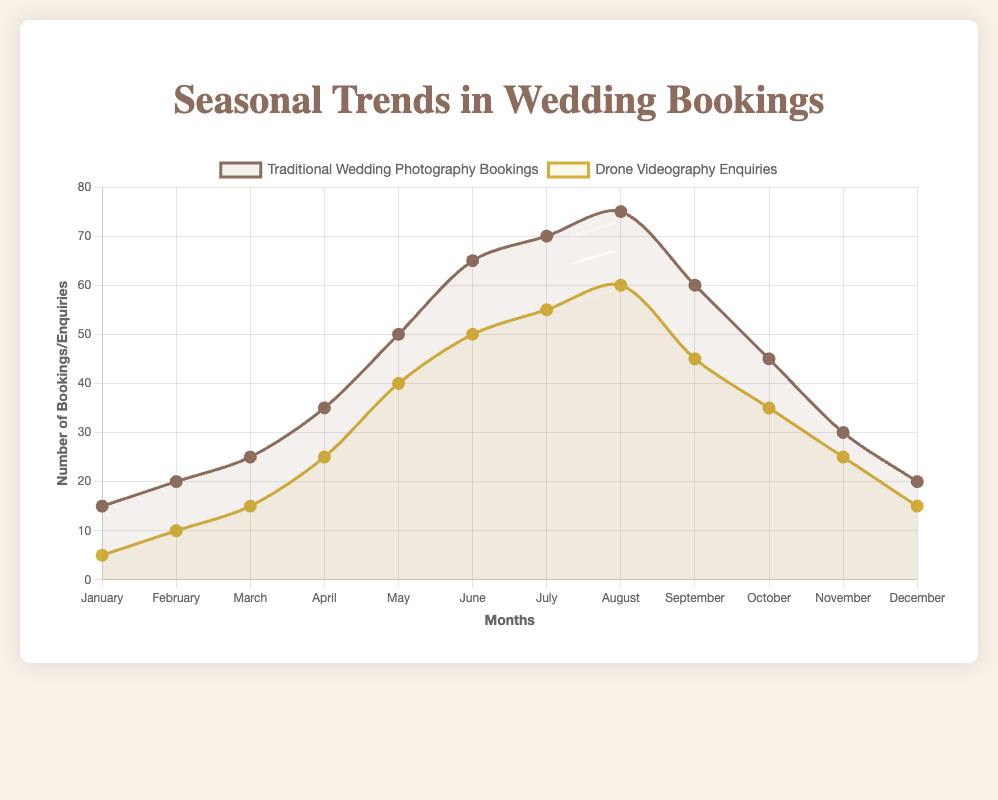What month has the highest number of traditional wedding photography bookings? Observe the line representing traditional wedding photography bookings. The highest point is in August.
Answer: August During which month does the number of drone videography enquiries first surpass 30? Look at the line representing drone videography enquiries. The first month it breaks the 30 mark is May.
Answer: May How does the number of traditional wedding photography bookings in June compare to the number of drone videography enquiries in the same month? In June, traditional wedding photography bookings are 65, and drone videography enquiries are 50. Comparing the two, traditional wedding photography bookings are greater.
Answer: Traditional wedding photography bookings are greater What is the difference between the highest number of traditional wedding photography bookings and the highest number of drone videography enquiries? The peak number for traditional bookings is 75, and for drone enquiries, it is 60. The difference is 75 - 60.
Answer: 15 During which month are the traditional wedding photography bookings equal to the drone videography enquiries? Review the chart for points where the lines intersect. They do not intersect at exact points, indicating no equal bookings in any month.
Answer: No month What is the average number of traditional wedding photography bookings from January to December? Sum the numbers for traditional bookings (15 + 20 + 25 + 35 + 50 + 65 + 70 + 75 + 60 + 45 + 30 + 20) = 510, then divide by 12 months.
Answer: 42.5 Which month sees the biggest discrepancy between traditional wedding photography bookings and drone videography enquiries? Calculate the difference for each month and find the largest: August has 75 traditional bookings and 60 drone enquiries, making the difference 15.
Answer: August What can be inferred about the trend of drone videography enquiries from January to August? The line representing drone videography enquiries shows a steady increase from January (5) to August (60).
Answer: Increasing steadily How many traditional wedding photography bookings are there in the first half of the year compared to the second half? Sum the bookings for Jan-Jun (15 + 20 + 25 + 35 + 50 + 65 = 210) and Jul-Dec (70 + 75 + 60 + 45 + 30 + 20 = 300), then compare the two.
Answer: 210 (first half), 300 (second half) Is there any month where drone videography enquiries decline from the previous month? Review the drone videography line for decreases; September drops to 45 from 60 in August, and November drops to 25 from 35 in October.
Answer: September, November 